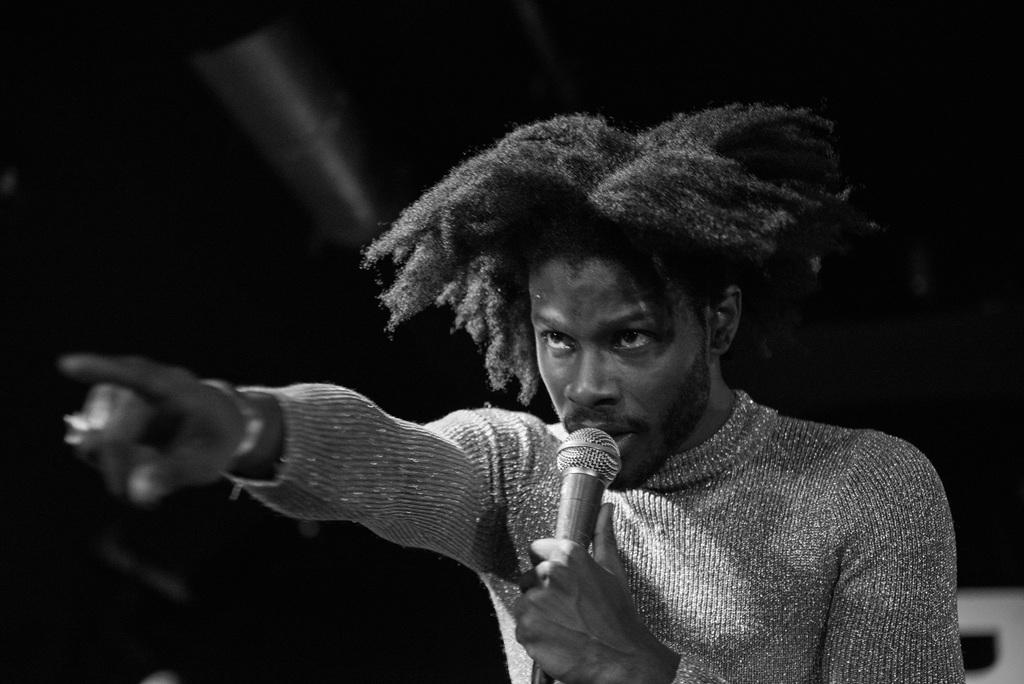What is the main subject of the image? The main subject of the image is a man. What is the man doing in the image? The man is standing and singing in the image. What tool is the man using while singing? The man is using a microphone in the image. Can you see any goats or cattle in the image? No, there are no goats or cattle present in the image. What type of play is the man participating in while holding the microphone? The provided facts do not mention any play or performance, so it cannot be determined from the image. 